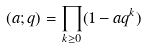Convert formula to latex. <formula><loc_0><loc_0><loc_500><loc_500>( a ; q ) & = \prod _ { k \geq 0 } ( 1 - a q ^ { k } )</formula> 